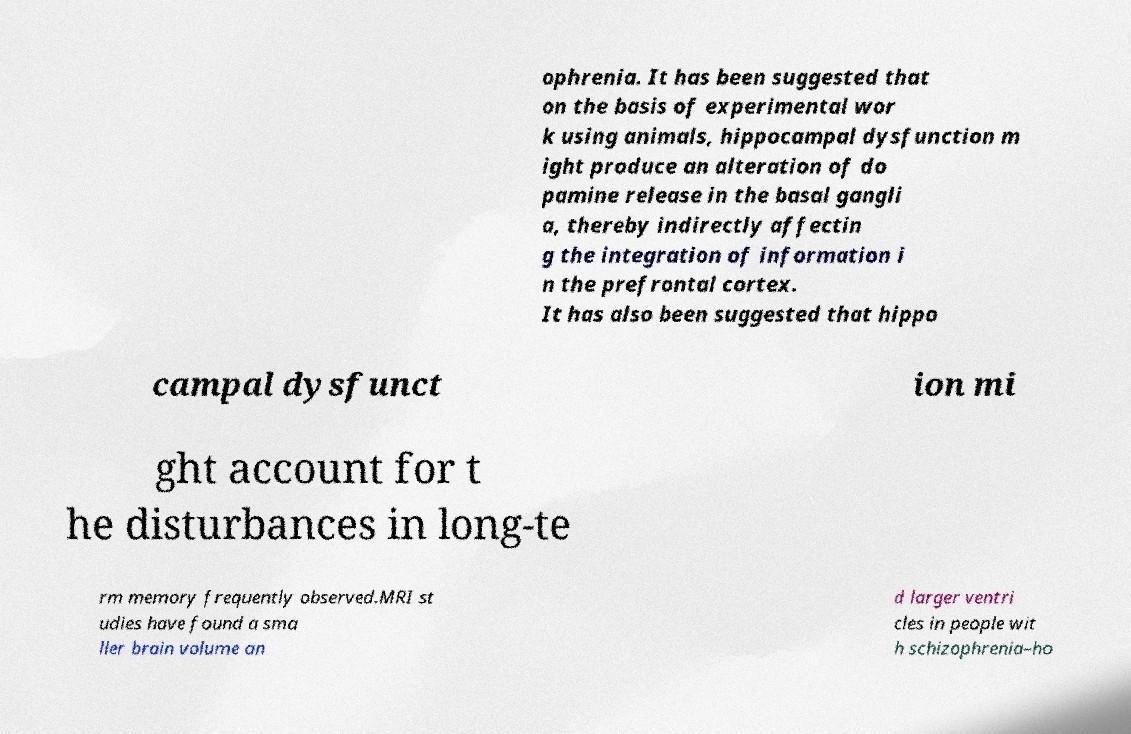I need the written content from this picture converted into text. Can you do that? ophrenia. It has been suggested that on the basis of experimental wor k using animals, hippocampal dysfunction m ight produce an alteration of do pamine release in the basal gangli a, thereby indirectly affectin g the integration of information i n the prefrontal cortex. It has also been suggested that hippo campal dysfunct ion mi ght account for t he disturbances in long-te rm memory frequently observed.MRI st udies have found a sma ller brain volume an d larger ventri cles in people wit h schizophrenia–ho 